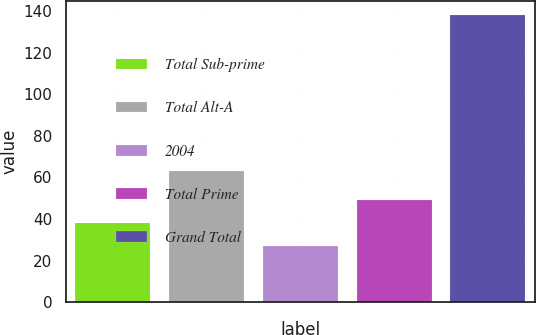Convert chart to OTSL. <chart><loc_0><loc_0><loc_500><loc_500><bar_chart><fcel>Total Sub-prime<fcel>Total Alt-A<fcel>2004<fcel>Total Prime<fcel>Grand Total<nl><fcel>38.1<fcel>63<fcel>27<fcel>49.2<fcel>138<nl></chart> 